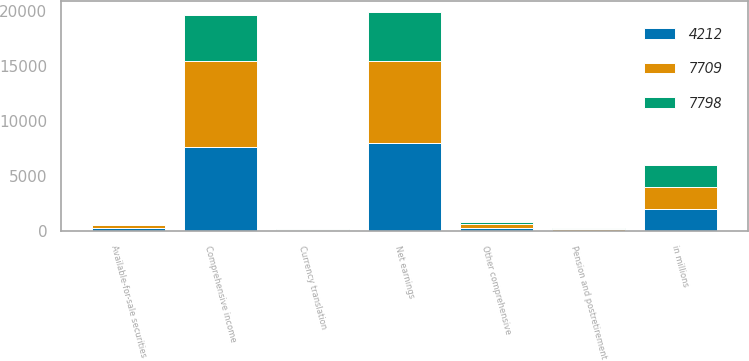Convert chart to OTSL. <chart><loc_0><loc_0><loc_500><loc_500><stacked_bar_chart><ecel><fcel>in millions<fcel>Net earnings<fcel>Currency translation<fcel>Pension and postretirement<fcel>Available-for-sale securities<fcel>Other comprehensive<fcel>Comprehensive income<nl><fcel>4212<fcel>2013<fcel>8040<fcel>50<fcel>38<fcel>327<fcel>331<fcel>7709<nl><fcel>7709<fcel>2012<fcel>7475<fcel>89<fcel>168<fcel>244<fcel>323<fcel>7798<nl><fcel>7798<fcel>2011<fcel>4442<fcel>55<fcel>145<fcel>30<fcel>230<fcel>4212<nl></chart> 